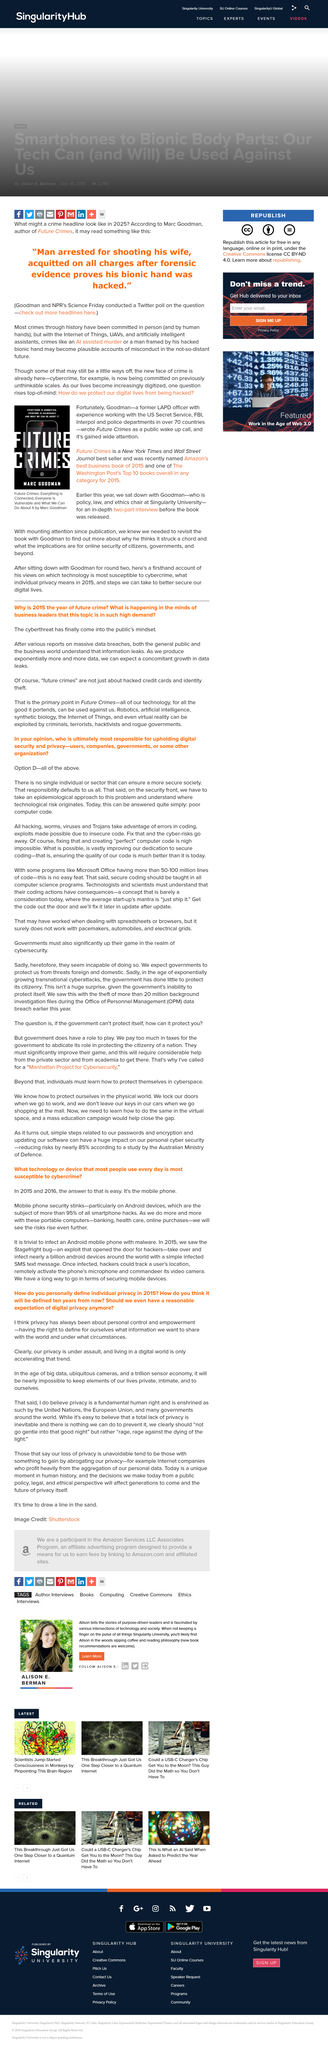Mention a couple of crucial points in this snapshot. The idea of being hacked by a bionic hand is a fictional concept that does not exist in reality, as stated in the book. In 2015, the Stagefright bug was discovered. Marc Goodman works at Singularity University, which is located at a university. Smartphone hacks are most frequently targeted towards Android devices. According to research, the mobile phone is the device that is most susceptible to cybercrime. 